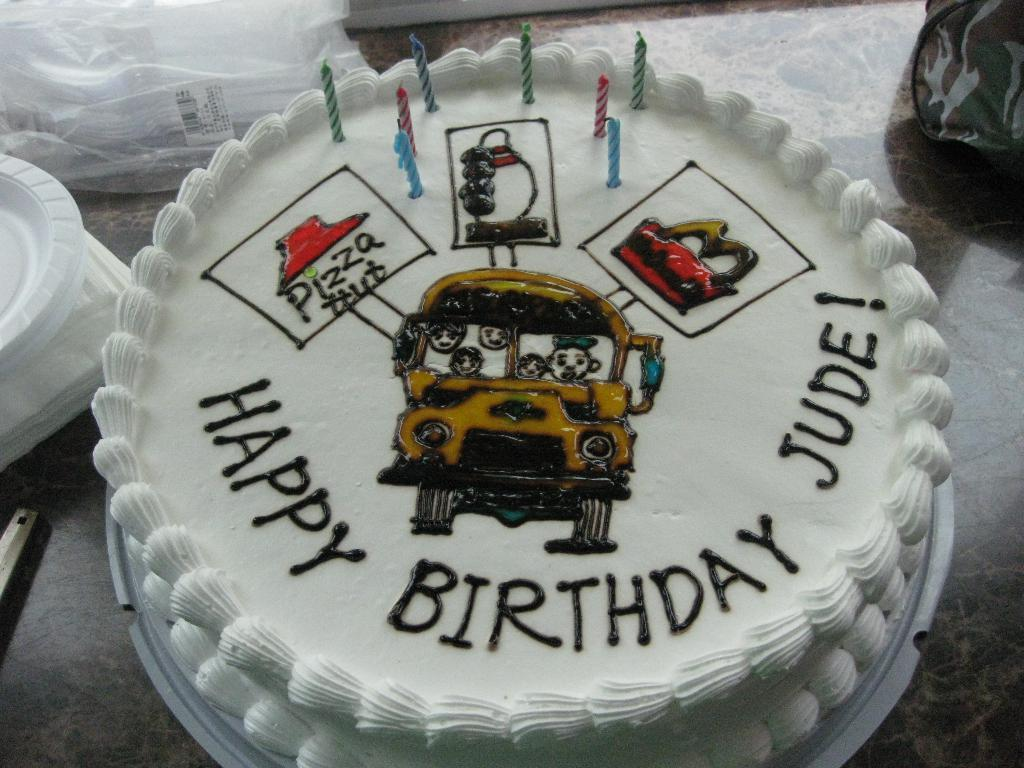What is the main subject of the image? There is a cake with candles in the image. What other items can be seen in the image? There are tissue papers, plates, and a cover visible in the image. What might be used for decoration or cleaning in the image? Tissue papers can be used for decoration or cleaning in the image. What is likely the surface on which these objects are placed? The objects are likely placed on a table, as there are other objects on the surface. Can you see a rake being used to clean the table in the image? There is no rake present in the image, and it is not being used to clean the table. What type of gold object can be seen on the cake in the image? There is no gold object present on the cake in the image. 